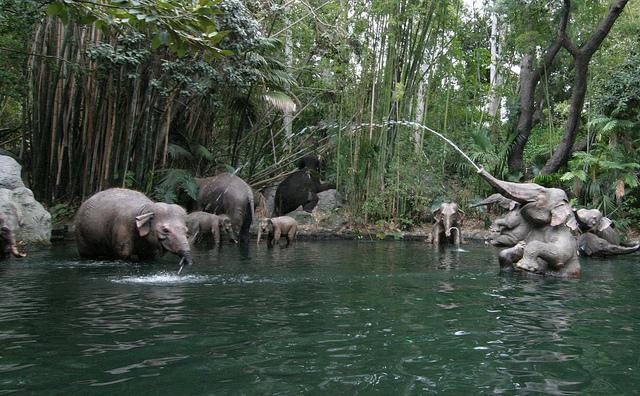How many elephants are there?
Give a very brief answer. 4. 